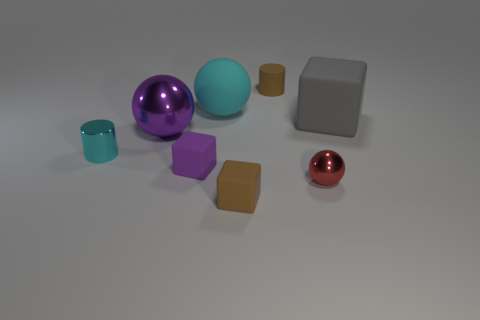Subtract all tiny brown rubber blocks. How many blocks are left? 2 Add 2 brown cylinders. How many objects exist? 10 Subtract all balls. How many objects are left? 5 Subtract all gray blocks. How many blocks are left? 2 Subtract all blue cylinders. Subtract all blue blocks. How many cylinders are left? 2 Subtract all cyan cylinders. How many brown balls are left? 0 Subtract all small blue rubber objects. Subtract all cyan rubber things. How many objects are left? 7 Add 3 big gray rubber things. How many big gray rubber things are left? 4 Add 8 big gray matte cylinders. How many big gray matte cylinders exist? 8 Subtract 0 blue cylinders. How many objects are left? 8 